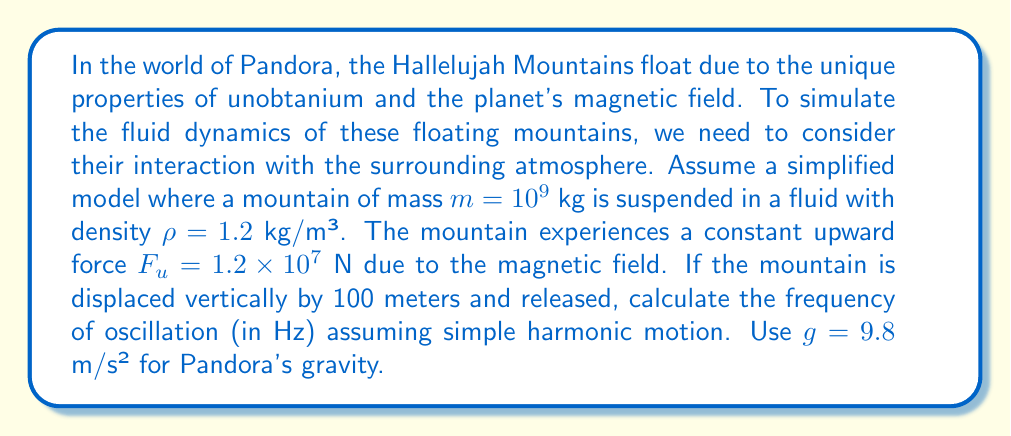What is the answer to this math problem? To solve this problem, we'll follow these steps:

1) First, we need to determine the net force acting on the mountain when it's displaced. This force will be the restoring force in our simple harmonic motion model.

2) The forces acting on the mountain are:
   - Gravity: $F_g = mg = 10^9 \times 9.8 = 9.8 \times 10^9$ N (downward)
   - Upward force due to magnetic field: $F_u = 1.2 \times 10^7$ N (given)
   - Buoyant force: $F_b = \rho gV$ (upward)

3) For the mountain to float at equilibrium, these forces must balance:
   $F_b + F_u = F_g$
   $\rho gV + 1.2 \times 10^7 = 9.8 \times 10^9$

4) Solving for V:
   $V = \frac{9.8 \times 10^9 - 1.2 \times 10^7}{\rho g} = 8.15 \times 10^8$ m³

5) When the mountain is displaced vertically, the buoyant force changes. The change in buoyant force acts as the restoring force:
   $F_{restore} = \rho g \Delta V = \rho g A \Delta y$
   where A is the cross-sectional area of the mountain.

6) For simple harmonic motion, $F = -ky$ where $k$ is the spring constant. So:
   $k = \rho g A$

7) The frequency of simple harmonic motion is given by:
   $f = \frac{1}{2\pi} \sqrt{\frac{k}{m}} = \frac{1}{2\pi} \sqrt{\frac{\rho g A}{m}}$

8) We can find A using $V = Ah$ where h is the height of the mountain. Assuming a roughly cubic shape, $h \approx V^{1/3}$, so:
   $A \approx V^{2/3} = (8.15 \times 10^8)^{2/3} = 4.06 \times 10^5$ m²

9) Now we can calculate the frequency:
   $f = \frac{1}{2\pi} \sqrt{\frac{1.2 \times 9.8 \times 4.06 \times 10^5}{10^9}} = 0.0352$ Hz
Answer: The frequency of oscillation is approximately 0.0352 Hz. 